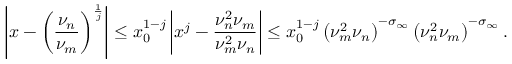Convert formula to latex. <formula><loc_0><loc_0><loc_500><loc_500>\left | x - \left ( \frac { \nu _ { n } } { \nu _ { m } } \right ) ^ { \frac { 1 } { j } } \right | \leq x _ { 0 } ^ { 1 - j } \left | x ^ { j } - \frac { \nu _ { n } ^ { 2 } \nu _ { m } } { \nu _ { m } ^ { 2 } \nu _ { n } } \right | \leq x _ { 0 } ^ { 1 - j } \left ( \nu _ { m } ^ { 2 } \nu _ { n } \right ) ^ { - \sigma _ { \infty } } \left ( \nu _ { n } ^ { 2 } \nu _ { m } \right ) ^ { - \sigma _ { \infty } } .</formula> 